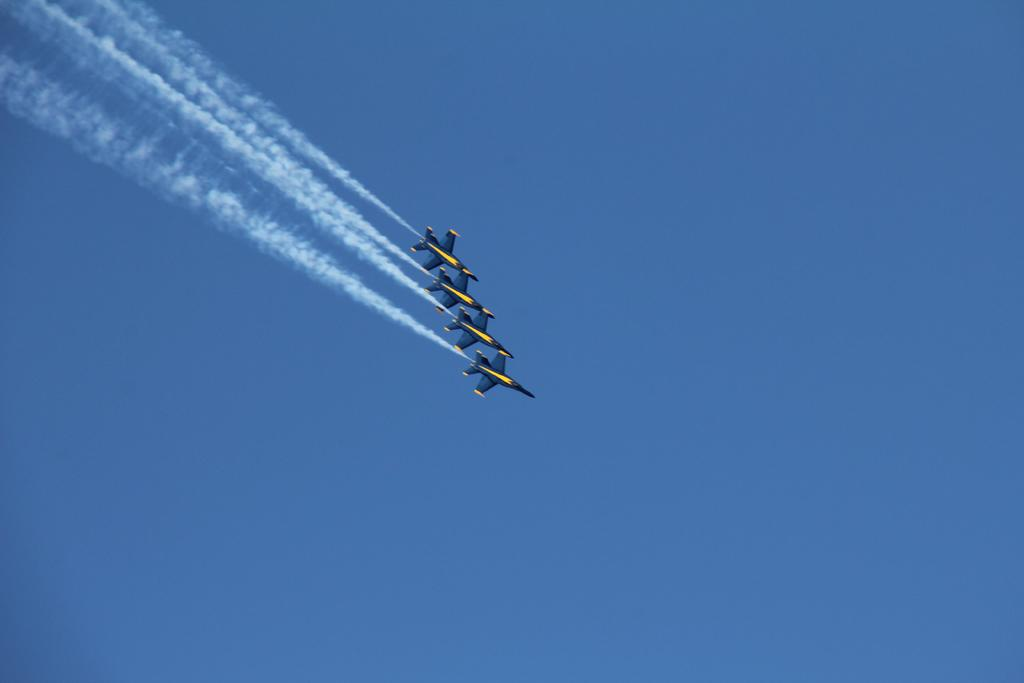What is the main subject of the image? The main subject of the image is aeroplanes. What are the aeroplanes doing in the image? The aeroplanes are flying in the sky. Where is the toy giraffe located in the image? There is no toy giraffe present in the image. How tall are the giants in the image? There are no giants present in the image. 